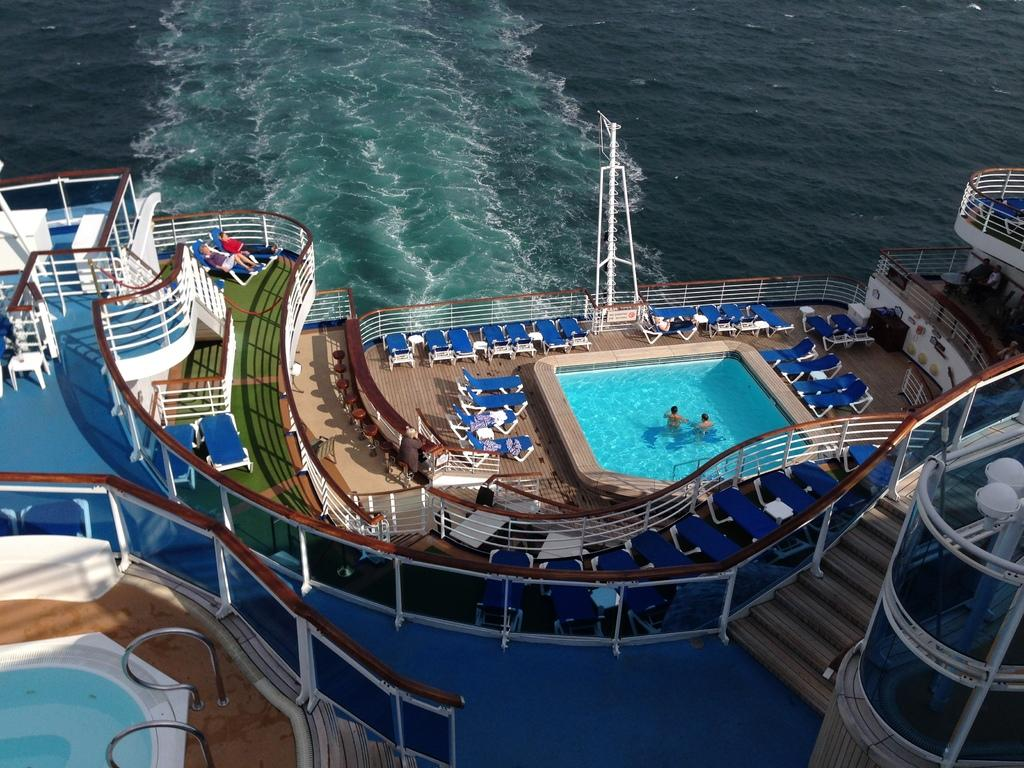What is the main subject of the picture? The main subject of the picture is a ship. What can be seen in the water in the picture? There is water visible in the picture, and swimming pools are present in the water. What type of structure is available for people to climb in the picture? There are stairs to climb in the picture. What type of furniture is available for people to sit on in the picture? There are chairs to sit in the picture. What are the people in the pool doing? There are people swimming in the pool. What are the people not in the pool doing? There are people seated in the picture. What type of silver is being used to make suggestions to the police in the image? There is no silver or police present in the image; it features a ship, water, swimming pools, stairs, chairs, people swimming, and people seated. 